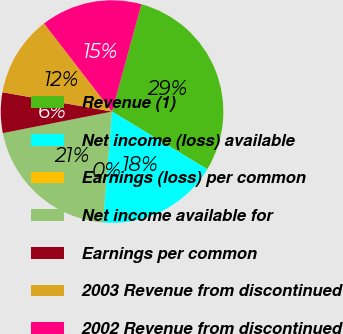Convert chart. <chart><loc_0><loc_0><loc_500><loc_500><pie_chart><fcel>Revenue (1)<fcel>Net income (loss) available<fcel>Earnings (loss) per common<fcel>Net income available for<fcel>Earnings per common<fcel>2003 Revenue from discontinued<fcel>2002 Revenue from discontinued<nl><fcel>29.41%<fcel>17.65%<fcel>0.0%<fcel>20.59%<fcel>5.88%<fcel>11.76%<fcel>14.71%<nl></chart> 